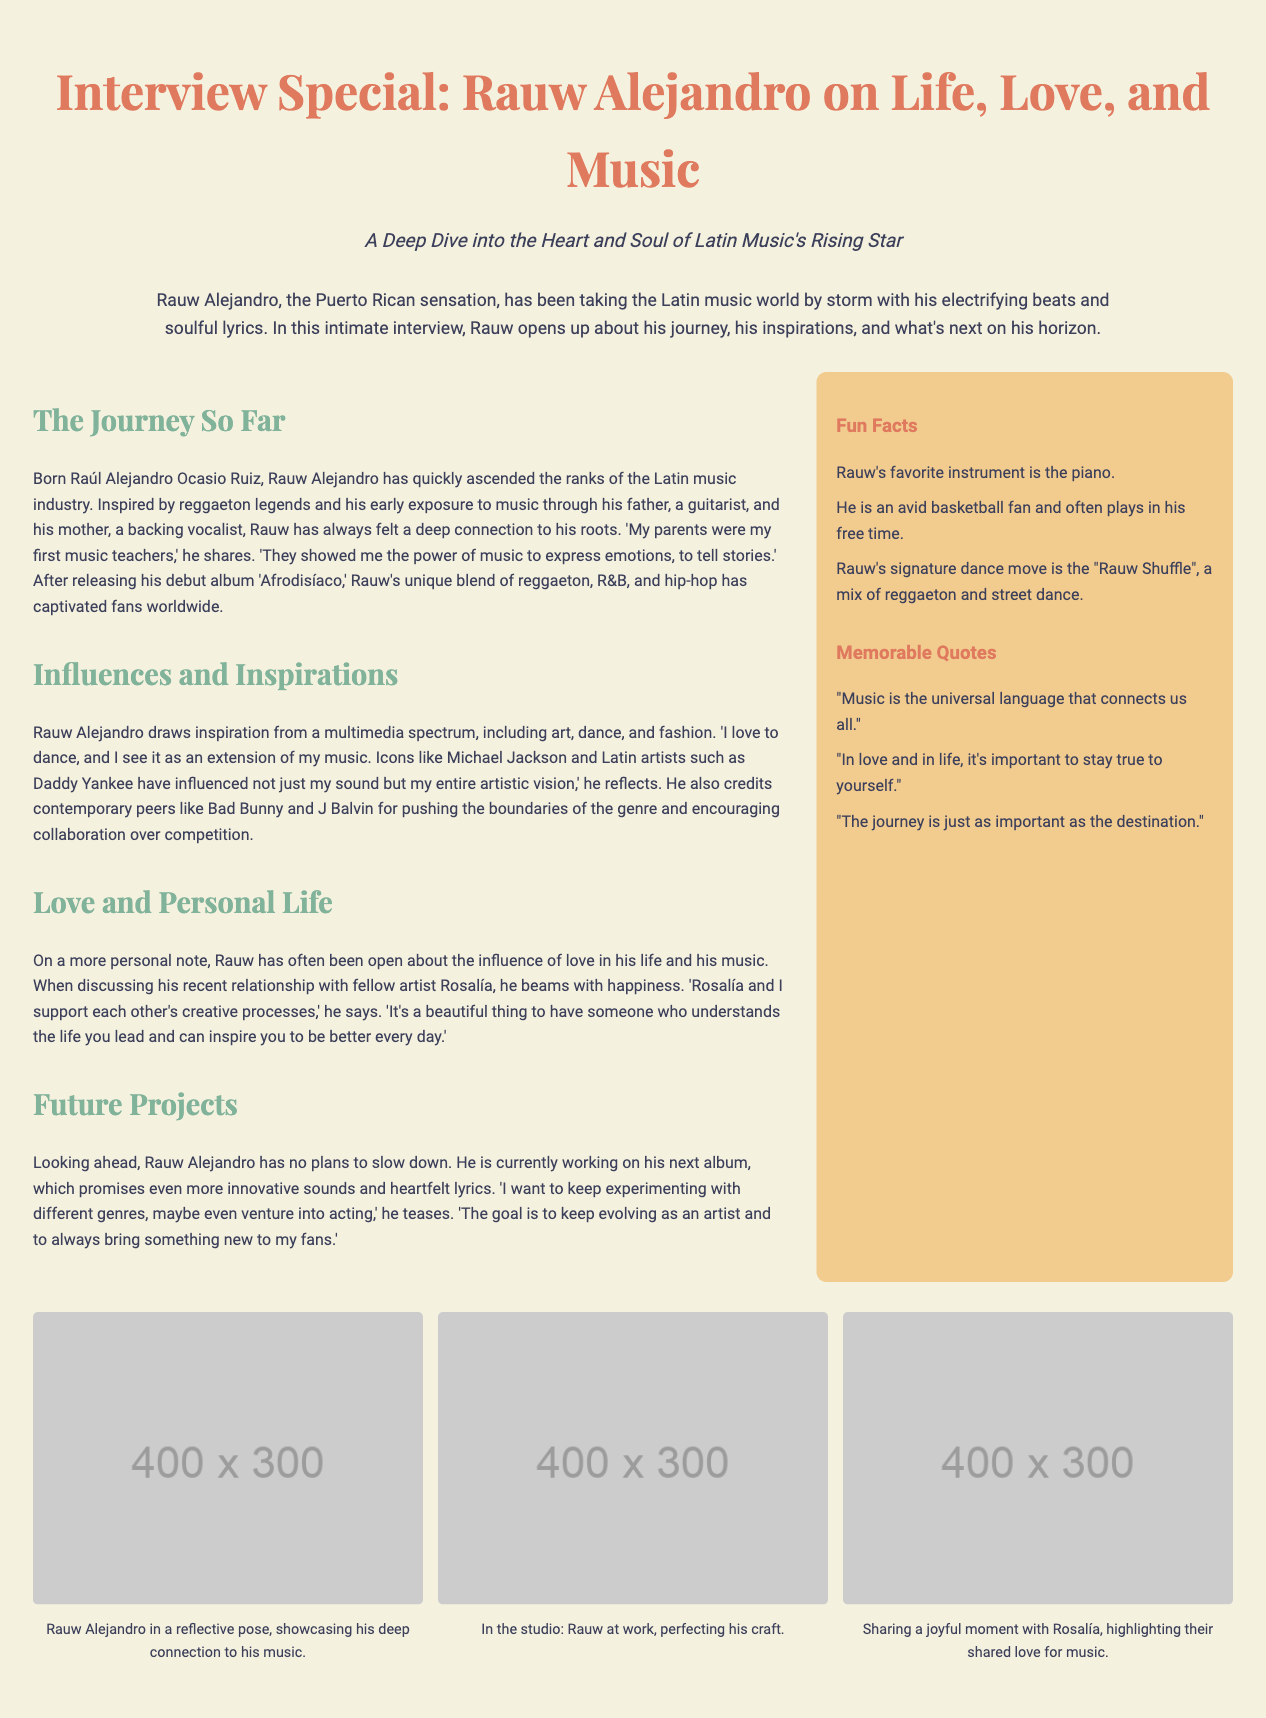What is Rauw Alejandro's full name? Rauw Alejandro's full name is mentioned in the section "The Journey So Far" as Raúl Alejandro Ocasio Ruiz.
Answer: Raúl Alejandro Ocasio Ruiz What is his debut album? The debut album of Rauw Alejandro is listed in the section "The Journey So Far" as 'Afrodisíaco'.
Answer: Afrodisíaco Who are Rauw Alejandro's influences? Influences mentioned in the document include Michael Jackson, Daddy Yankee, Bad Bunny, and J Balvin.
Answer: Michael Jackson, Daddy Yankee, Bad Bunny, J Balvin What unique dance move is associated with Rauw Alejandro? The dance move attributed to Rauw Alejandro is referred to in the sidebar under fun facts as the "Rauw Shuffle".
Answer: Rauw Shuffle How does Rauw Alejandro feel about his relationship with Rosalía? His feelings about his relationship with Rosalía are expressed as supportive and inspiring, particularly in the section "Love and Personal Life".
Answer: Supportive and inspiring What genre fusion does Rauw Alejandro mention in his upcoming projects? Rauw Alejandro mentions experimenting with different genres in the section "Future Projects".
Answer: Different genres What is Rauw Alejandro's favorite instrument? Rauw's favorite instrument is specified in the sidebar under fun facts as the piano.
Answer: Piano What is one of Rauw Alejandro's memorable quotes? One memorable quote from Rauw Alejandro is provided in the sidebar under quotes: "Music is the universal language that connects us all."
Answer: "Music is the universal language that connects us all." What future project does Rauw Alejandro tease? He teases potentially venturing into acting in the section "Future Projects".
Answer: Acting 